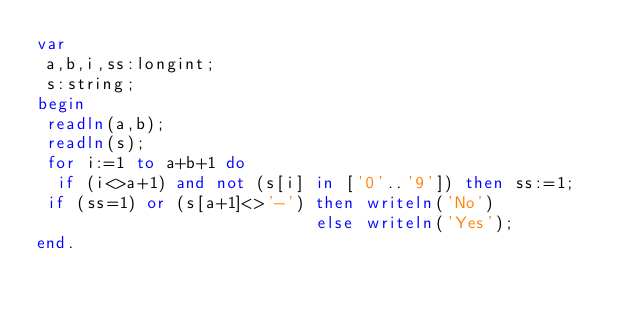<code> <loc_0><loc_0><loc_500><loc_500><_Pascal_>var
 a,b,i,ss:longint;
 s:string;
begin
 readln(a,b);
 readln(s);
 for i:=1 to a+b+1 do
  if (i<>a+1) and not (s[i] in ['0'..'9']) then ss:=1;
 if (ss=1) or (s[a+1]<>'-') then writeln('No')
                            else writeln('Yes');
end.</code> 